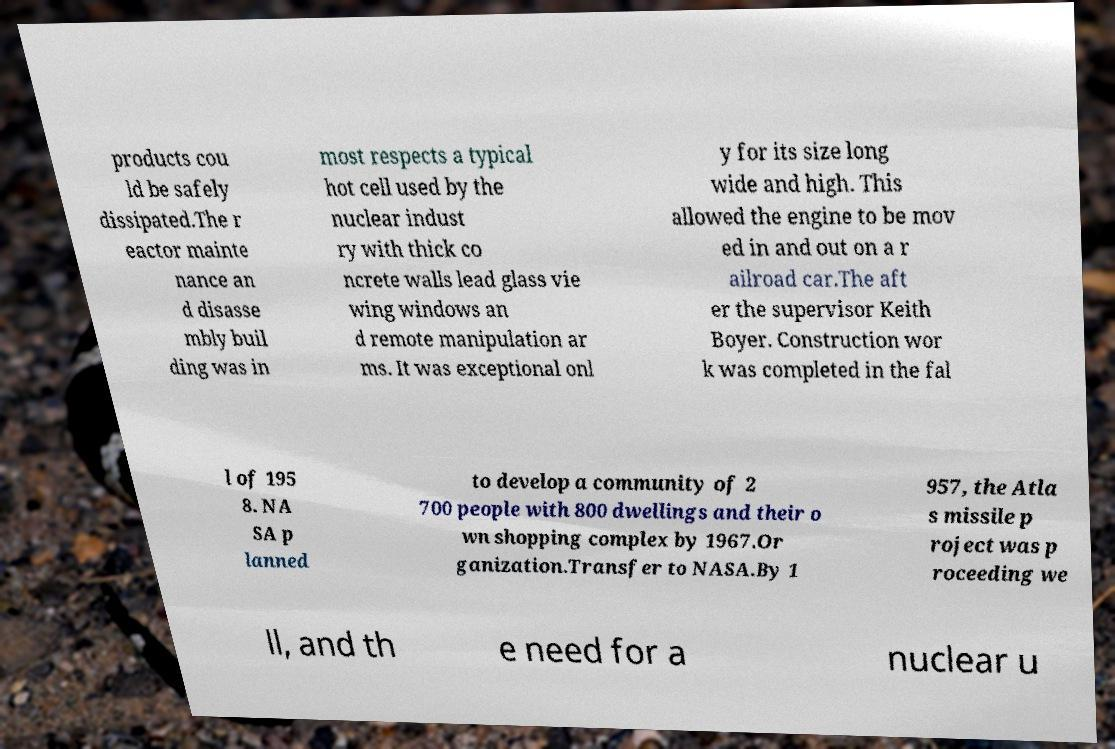Can you accurately transcribe the text from the provided image for me? products cou ld be safely dissipated.The r eactor mainte nance an d disasse mbly buil ding was in most respects a typical hot cell used by the nuclear indust ry with thick co ncrete walls lead glass vie wing windows an d remote manipulation ar ms. It was exceptional onl y for its size long wide and high. This allowed the engine to be mov ed in and out on a r ailroad car.The aft er the supervisor Keith Boyer. Construction wor k was completed in the fal l of 195 8. NA SA p lanned to develop a community of 2 700 people with 800 dwellings and their o wn shopping complex by 1967.Or ganization.Transfer to NASA.By 1 957, the Atla s missile p roject was p roceeding we ll, and th e need for a nuclear u 